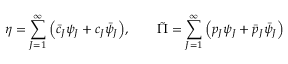Convert formula to latex. <formula><loc_0><loc_0><loc_500><loc_500>\eta = \sum _ { J = 1 } ^ { \infty } \left ( \bar { c } _ { J } \psi _ { J } + c _ { J } \bar { \psi } _ { J } \right ) , \quad \tilde { \Pi } = \sum _ { J = 1 } ^ { \infty } \left ( { p } _ { J } \psi _ { J } + \bar { p } _ { J } \bar { \psi } _ { J } \right )</formula> 